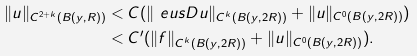<formula> <loc_0><loc_0><loc_500><loc_500>\| u \| _ { C ^ { 2 + k } ( B ( y , R ) ) } & < C ( \| \ e u s { D } u \| _ { C ^ { k } ( B ( y , 2 R ) ) } + \| u \| _ { C ^ { 0 } ( B ( y , 2 R ) ) } ) \\ & < C ^ { \prime } ( \| f \| _ { C ^ { k } ( B ( y , 2 R ) ) } + \| u \| _ { C ^ { 0 } ( B ( y , 2 R ) ) } ) .</formula> 